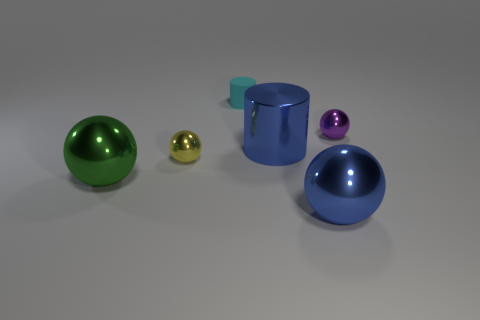What is the size of the object that is the same color as the big metallic cylinder?
Provide a short and direct response. Large. Are there any shiny balls of the same color as the metallic cylinder?
Make the answer very short. Yes. What shape is the object that is both on the right side of the shiny cylinder and in front of the purple sphere?
Provide a succinct answer. Sphere. Is the number of spheres right of the large blue ball the same as the number of large blue shiny things that are on the right side of the purple shiny ball?
Offer a very short reply. No. What number of objects are red cubes or small metallic balls?
Offer a terse response. 2. The rubber cylinder that is the same size as the purple metal ball is what color?
Offer a terse response. Cyan. What number of objects are either yellow shiny spheres that are on the right side of the big green object or small objects in front of the small purple shiny object?
Your answer should be compact. 1. Are there an equal number of large green objects that are on the right side of the purple object and blue objects?
Provide a succinct answer. No. Does the cyan matte object that is to the left of the small purple metal ball have the same size as the blue metallic thing behind the large green metallic sphere?
Give a very brief answer. No. There is a ball that is on the left side of the small metallic sphere to the left of the big metallic cylinder; is there a green metallic thing that is left of it?
Give a very brief answer. No. 